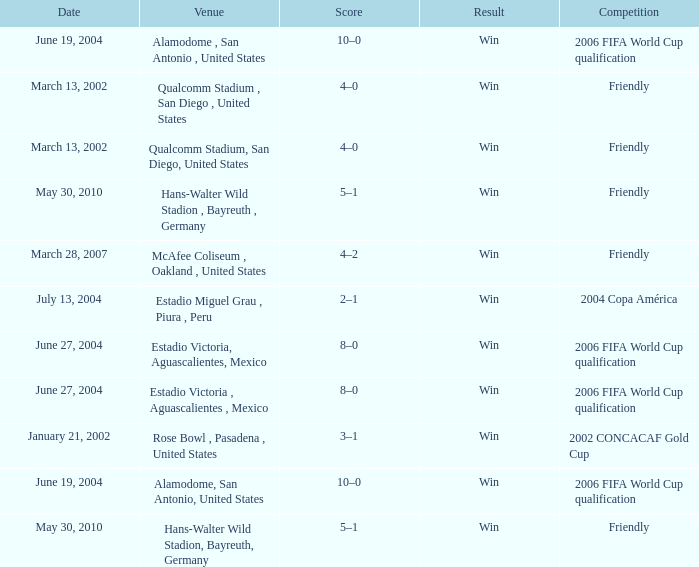Parse the table in full. {'header': ['Date', 'Venue', 'Score', 'Result', 'Competition'], 'rows': [['June 19, 2004', 'Alamodome , San Antonio , United States', '10–0', 'Win', '2006 FIFA World Cup qualification'], ['March 13, 2002', 'Qualcomm Stadium , San Diego , United States', '4–0', 'Win', 'Friendly'], ['March 13, 2002', 'Qualcomm Stadium, San Diego, United States', '4–0', 'Win', 'Friendly'], ['May 30, 2010', 'Hans-Walter Wild Stadion , Bayreuth , Germany', '5–1', 'Win', 'Friendly'], ['March 28, 2007', 'McAfee Coliseum , Oakland , United States', '4–2', 'Win', 'Friendly'], ['July 13, 2004', 'Estadio Miguel Grau , Piura , Peru', '2–1', 'Win', '2004 Copa América'], ['June 27, 2004', 'Estadio Victoria, Aguascalientes, Mexico', '8–0', 'Win', '2006 FIFA World Cup qualification'], ['June 27, 2004', 'Estadio Victoria , Aguascalientes , Mexico', '8–0', 'Win', '2006 FIFA World Cup qualification'], ['January 21, 2002', 'Rose Bowl , Pasadena , United States', '3–1', 'Win', '2002 CONCACAF Gold Cup'], ['June 19, 2004', 'Alamodome, San Antonio, United States', '10–0', 'Win', '2006 FIFA World Cup qualification'], ['May 30, 2010', 'Hans-Walter Wild Stadion, Bayreuth, Germany', '5–1', 'Win', 'Friendly']]} What event's outcome is dated january 21, 2002? Win. 